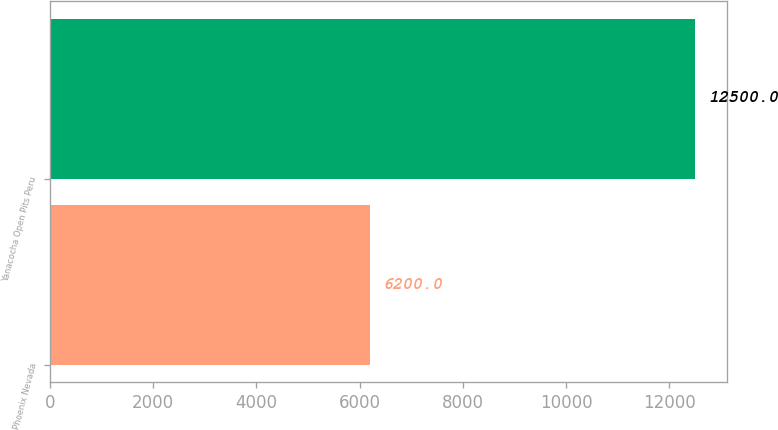Convert chart to OTSL. <chart><loc_0><loc_0><loc_500><loc_500><bar_chart><fcel>Phoenix Nevada<fcel>Yanacocha Open Pits Peru<nl><fcel>6200<fcel>12500<nl></chart> 